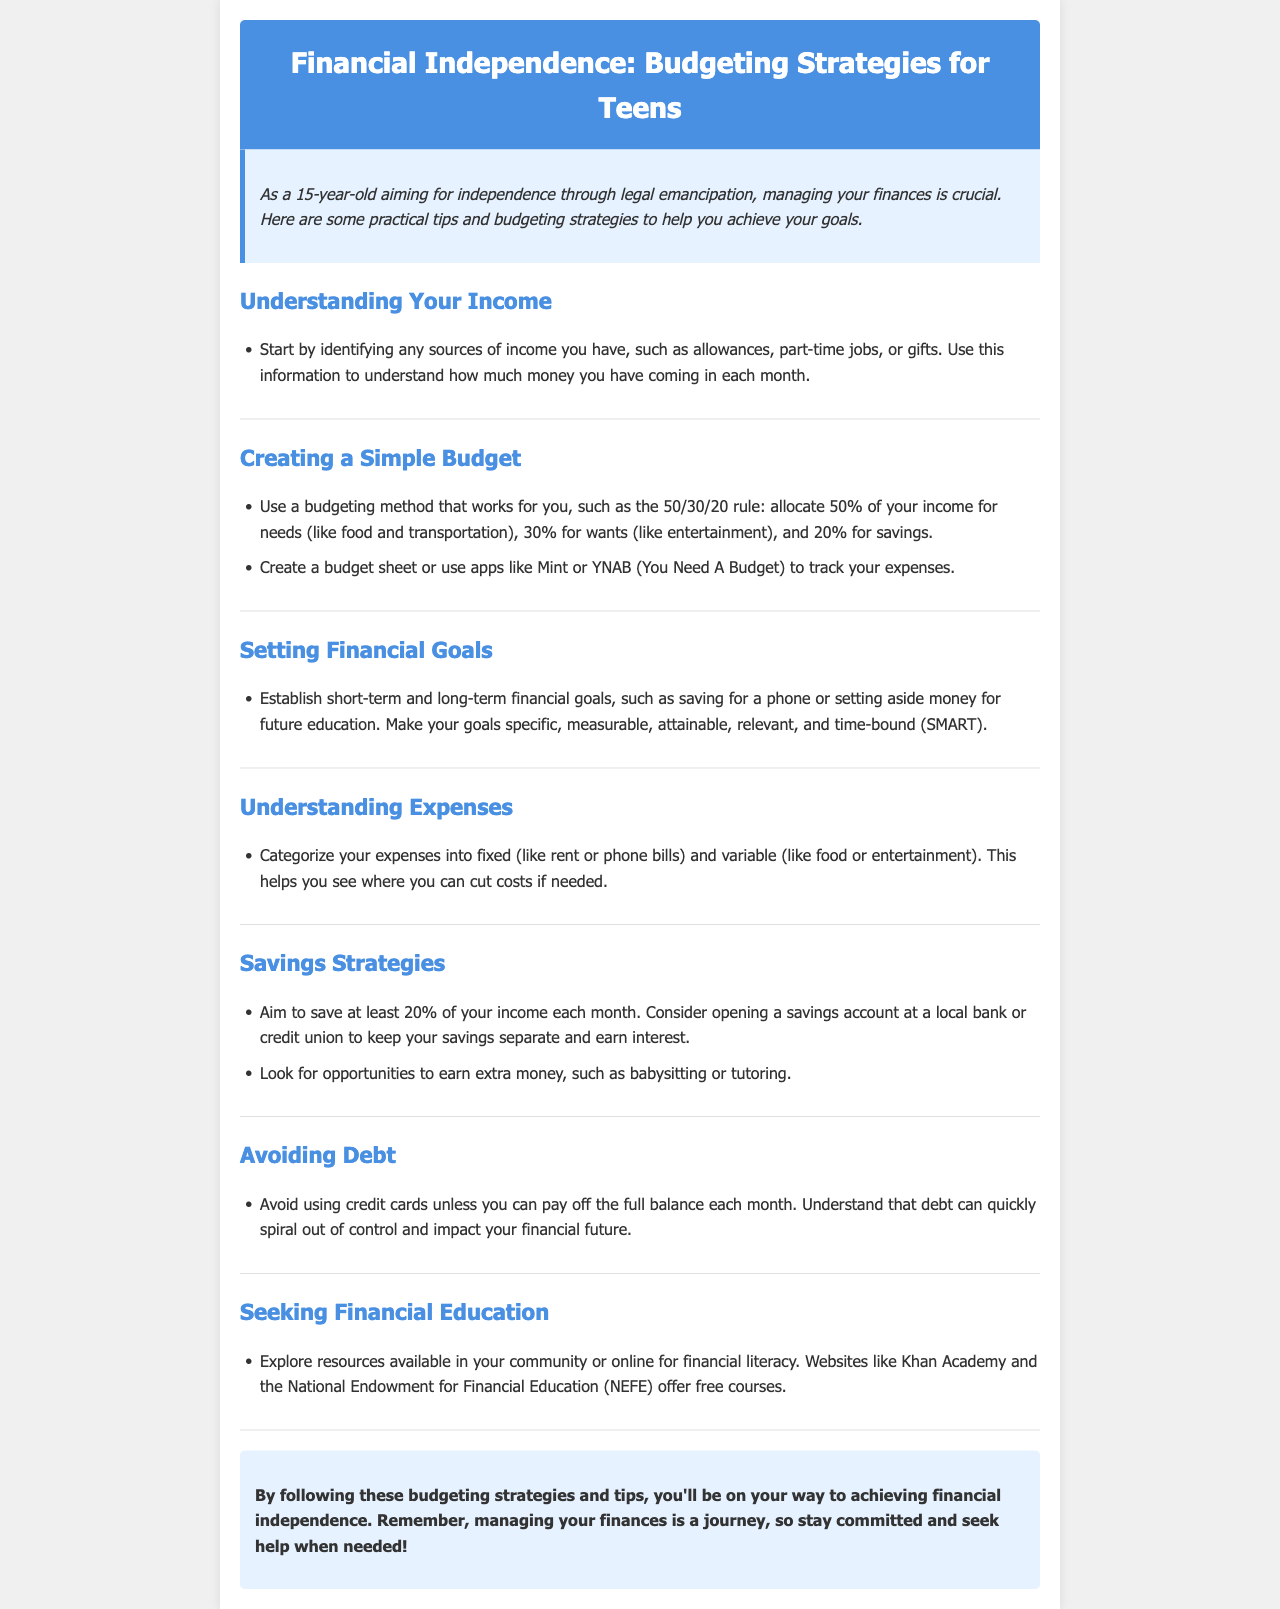what is the title of the newsletter? The title is stated prominently in the header section of the document.
Answer: Financial Independence: Budgeting Strategies for Teens how much of your income should you aim to save each month? The document specifies a savings goal as a percentage of income within the Savings Strategies section.
Answer: 20% name a budgeting app mentioned in the document. The document lists specific apps in the Creating a Simple Budget section as useful tools for budgeting.
Answer: Mint what does the acronym SMART stand for in the context of goals? The document introduces the SMART criteria for setting financial goals but does not expand what it stands for.
Answer: Specific, Measurable, Attainable, Relevant, Time-bound what should you avoid using unless you can pay off the full balance? The document warns against using certain financial tools in the Avoiding Debt section.
Answer: Credit cards how can you categorize your expenses? The document provides guidance on categorizing expenses in the Understanding Expenses section.
Answer: Fixed and variable what is a resource for financial education mentioned in the document? The document lists websites that provide financial literacy resources in the Seeking Financial Education section.
Answer: Khan Academy what is the purpose of tracking your expenses? The document discusses the importance of monitoring expenses in order to manage finances better.
Answer: To see where you can cut costs what does the intro suggest is crucial for achieving independence? The introduction emphasizes a key aspect of independence.
Answer: Managing your finances 